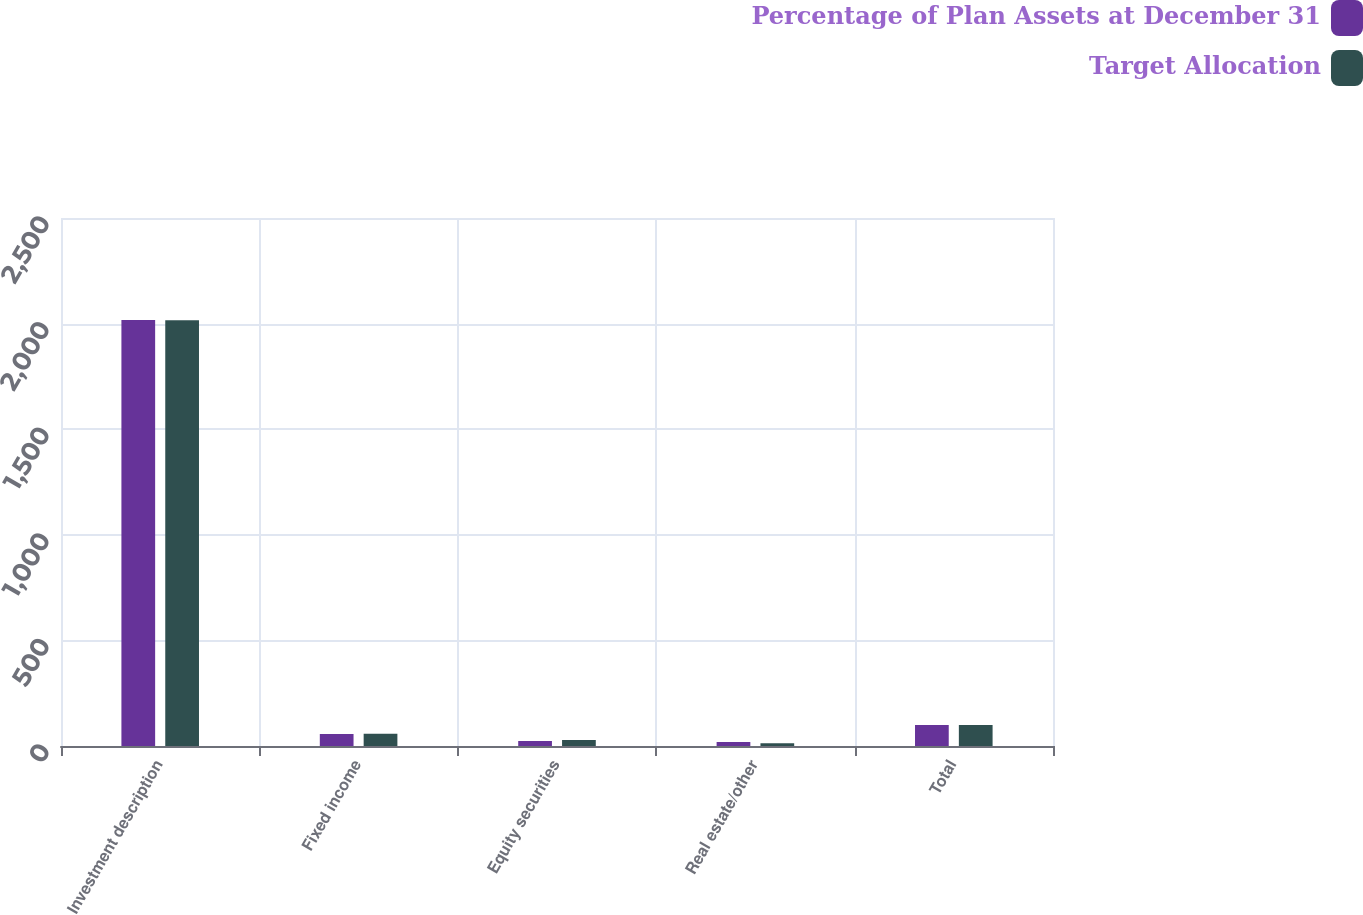<chart> <loc_0><loc_0><loc_500><loc_500><stacked_bar_chart><ecel><fcel>Investment description<fcel>Fixed income<fcel>Equity securities<fcel>Real estate/other<fcel>Total<nl><fcel>Percentage of Plan Assets at December 31<fcel>2017<fcel>57<fcel>24<fcel>19<fcel>100<nl><fcel>Target Allocation<fcel>2016<fcel>57.8<fcel>29<fcel>13.2<fcel>100<nl></chart> 